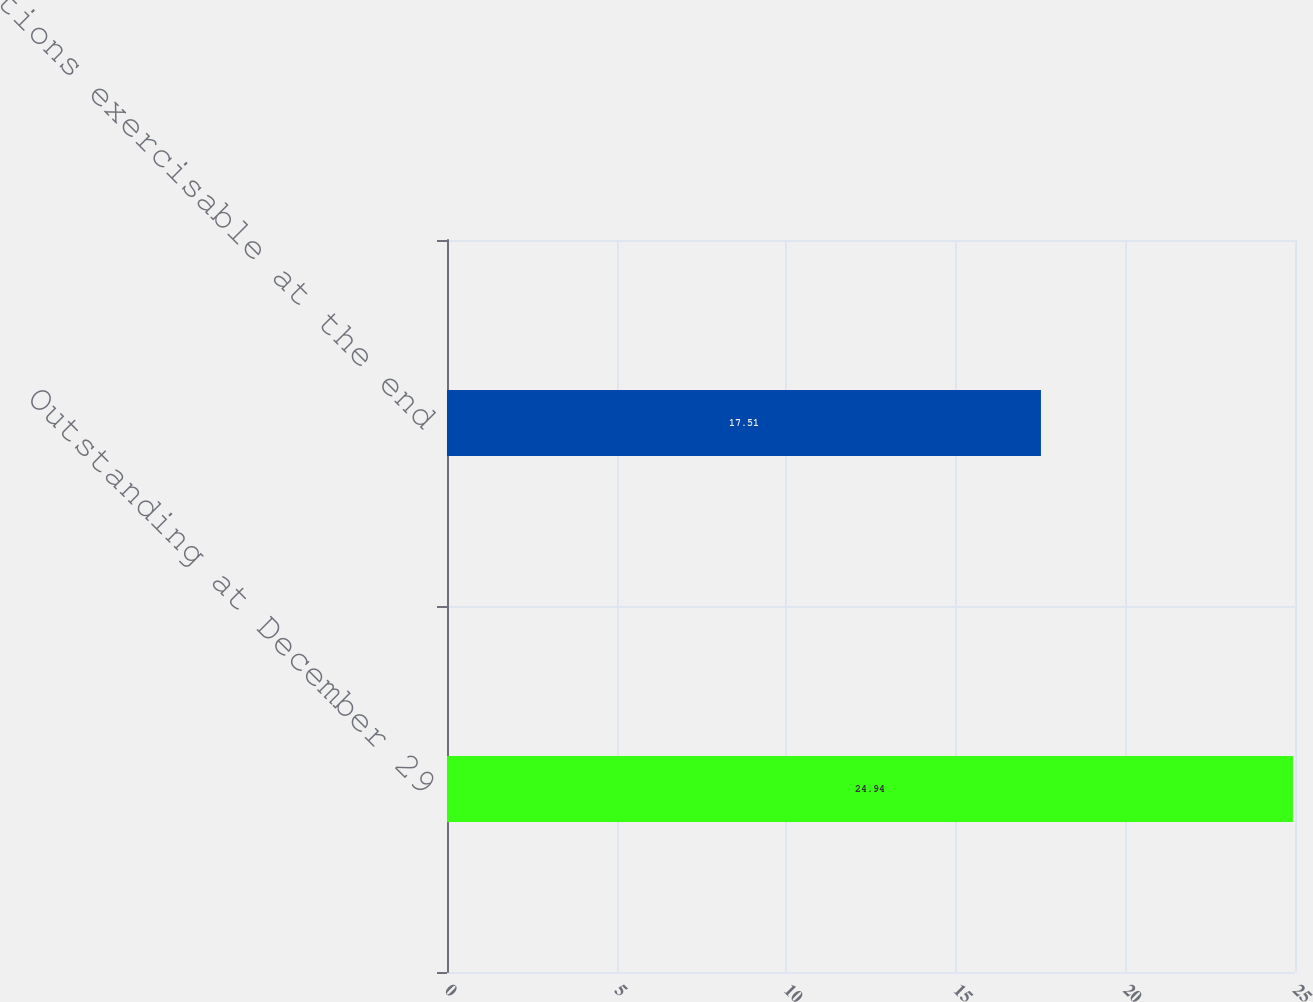Convert chart to OTSL. <chart><loc_0><loc_0><loc_500><loc_500><bar_chart><fcel>Outstanding at December 29<fcel>Options exercisable at the end<nl><fcel>24.94<fcel>17.51<nl></chart> 